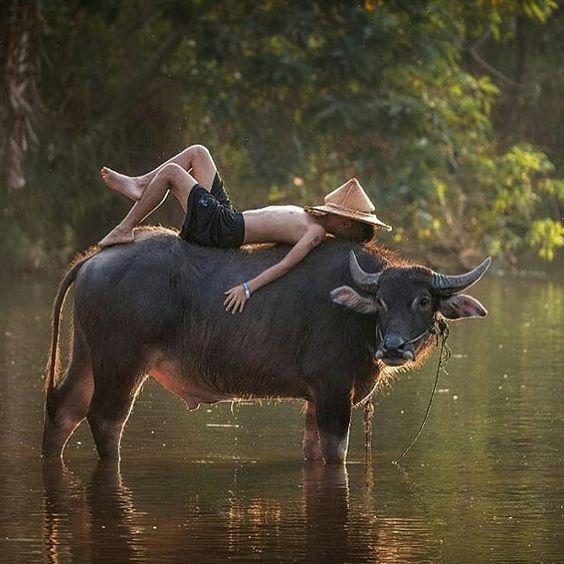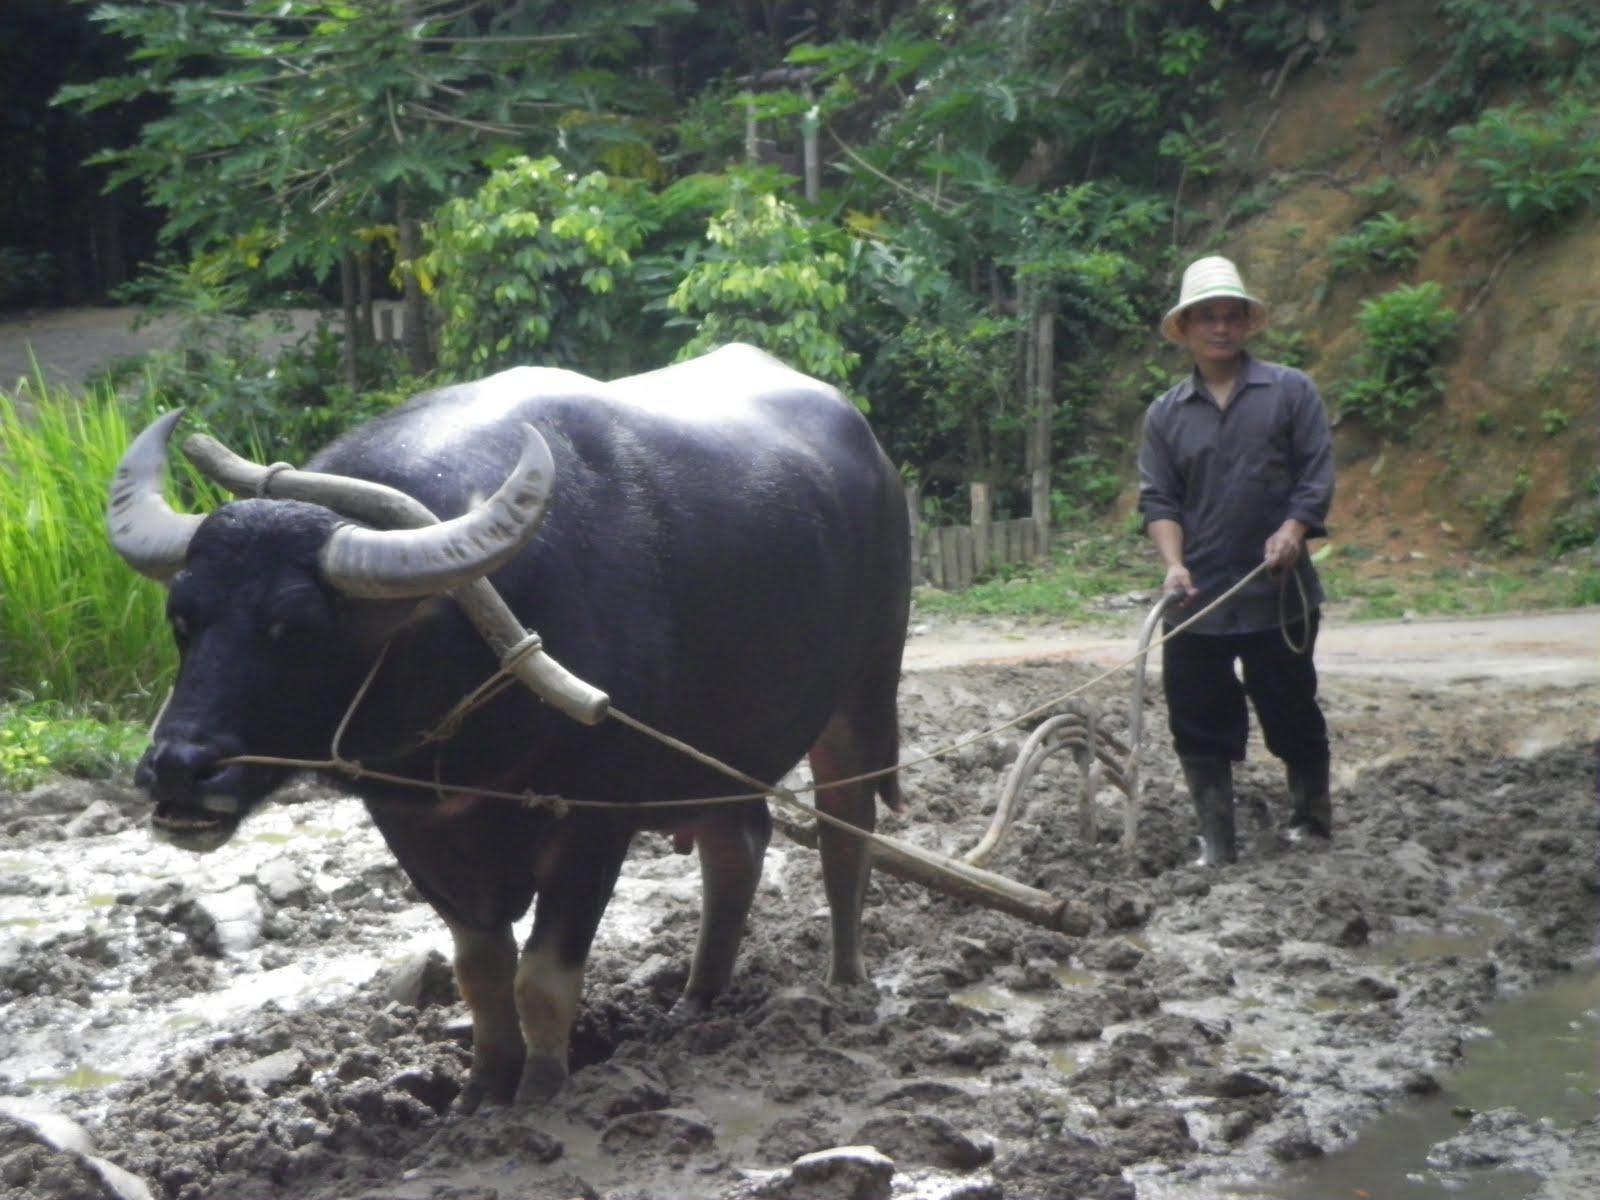The first image is the image on the left, the second image is the image on the right. Assess this claim about the two images: "A small boy straddles a horned cow in the image on the left.". Correct or not? Answer yes or no. No. 